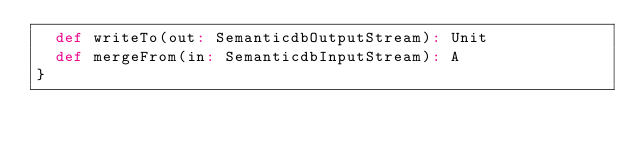<code> <loc_0><loc_0><loc_500><loc_500><_Scala_>  def writeTo(out: SemanticdbOutputStream): Unit
  def mergeFrom(in: SemanticdbInputStream): A
}
</code> 